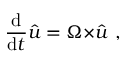<formula> <loc_0><loc_0><loc_500><loc_500>{ \frac { d } { d t } } { \hat { u } } = { \Omega \times } { \hat { u } } \ ,</formula> 